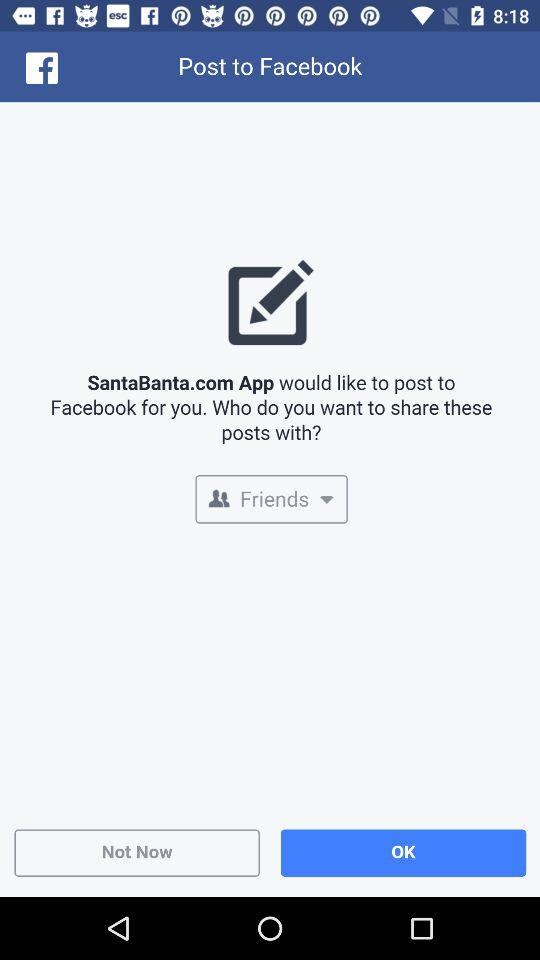What is the selected privacy to share the post? The selected privacy is "Friends". 